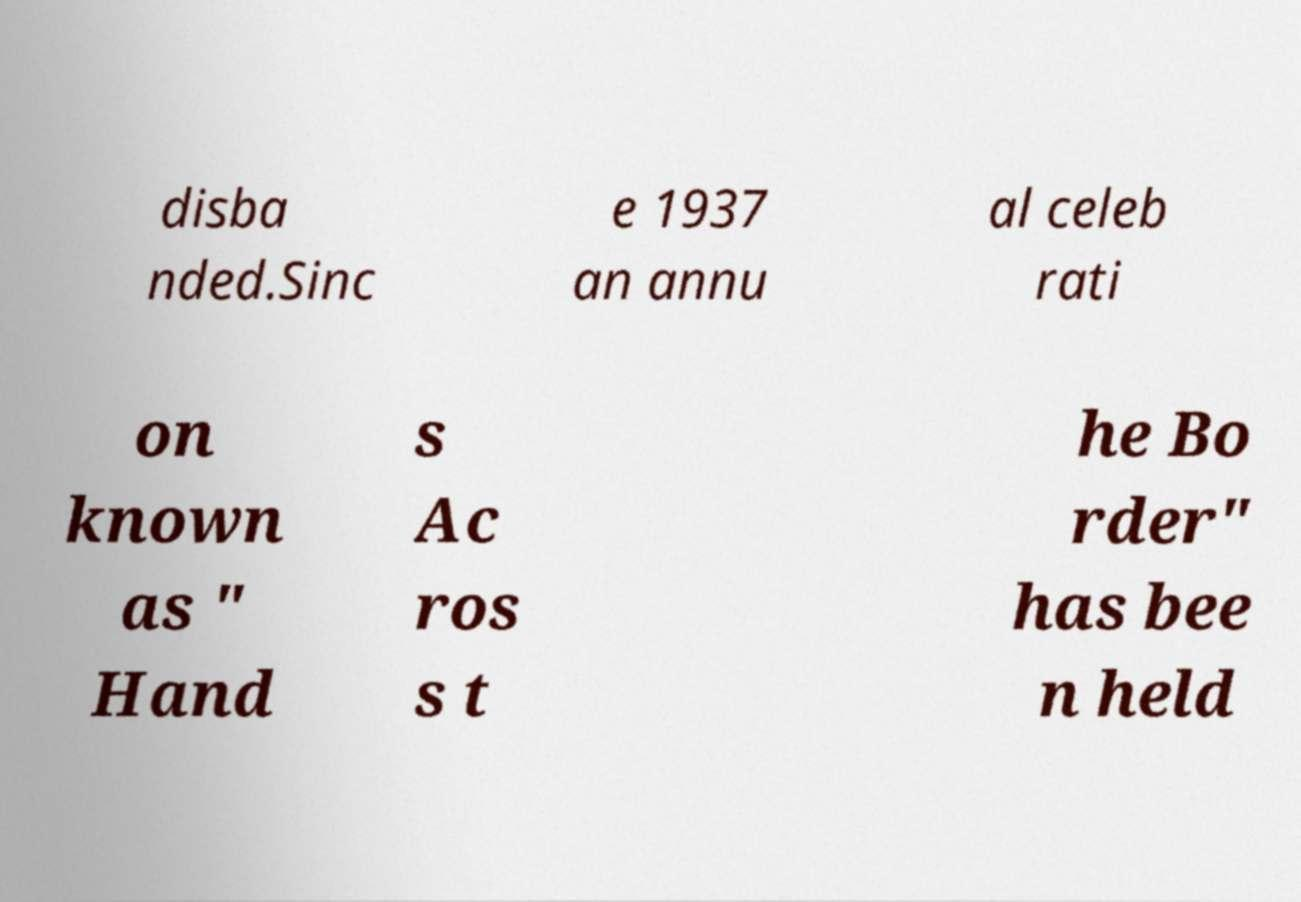There's text embedded in this image that I need extracted. Can you transcribe it verbatim? disba nded.Sinc e 1937 an annu al celeb rati on known as " Hand s Ac ros s t he Bo rder" has bee n held 